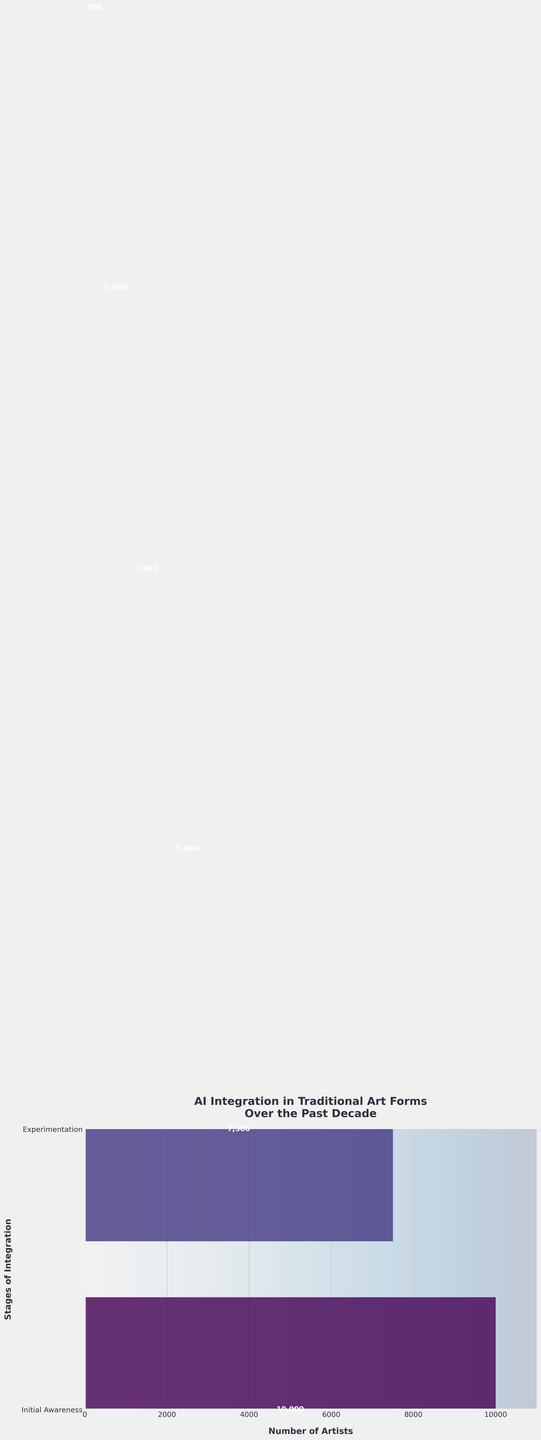what is the title of the chart? The title is located at the top of the chart. It is usually in a larger font size, making it easily identifiable. In this case, the title mentions "AI Integration in Traditional Art Forms Over the Past Decade."
Answer: AI Integration in Traditional Art Forms Over the Past Decade what does the x-axis represent? The x-axis often represents a quantitative variable. In this chart, it represents the "Number of Artists," as mentioned in the x-axis label beneath the primary plot area.
Answer: Number of Artists which stage has the fewest artists? Observing the funnel chart, you can see which bar is the shortest. The stage named "Pioneering New Art Forms" is associated with the smallest bar, indicating the fewest artists.
Answer: Pioneering New Art Forms how many artists are in the Basic Integration stage? The number of artists in each stage is written inside the bars. For "Basic Integration," the number written is "5000."
Answer: 5000 how does the number of artists in the Advanced Applications stage compare to the Full AI Collaboration stage? The funnel chart shows two horizontal bars for these stages. The "Advanced Applications" stage has a bar that is longer and has the number "3000," while "Full AI Collaboration" has a number and bar for "1500."
Answer: Advanced Applications has more artists what is the total number of artists participating in all stages? To find the total number of artists, sum the values of all stages. 10000 (Initial Awareness) + 7500 (Experimentation) + 5000 (Basic Integration) + 3000 (Advanced Applications) + 1500 (Full AI Collaboration) + 500 (Pioneering New Art Forms). The total is 27500.
Answer: 27500 which stage has more artists: Experimentation or Initial Awareness? By visually comparing the lengths and the written numbers of the bars for "Experimentation" (7500) and "Initial Awareness" (10000), you can see that "Initial Awareness" has more artists.
Answer: Initial Awareness how is the color gradient progressing through the chart? The color gradient in the chart uses shades transitioning from one color to another. According to the description, the color progresses as a gradient from one stage to the next within a viridis color spectrum.
Answer: Viridis gradient what is the average number of artists across all stages? To find the average, sum the total number of artists (27500) and divide by the number of stages (6). Thus, 27500 divided by 6 equals approximately 4583.33.
Answer: 4583.33 what pattern does the number of artists follow across the stages? By observing the funnel chart, the number of artists decreases at each stage from "Initial Awareness" to "Pioneering New Art Forms." This indicates a progressively narrowing engagement.
Answer: Decreasing 